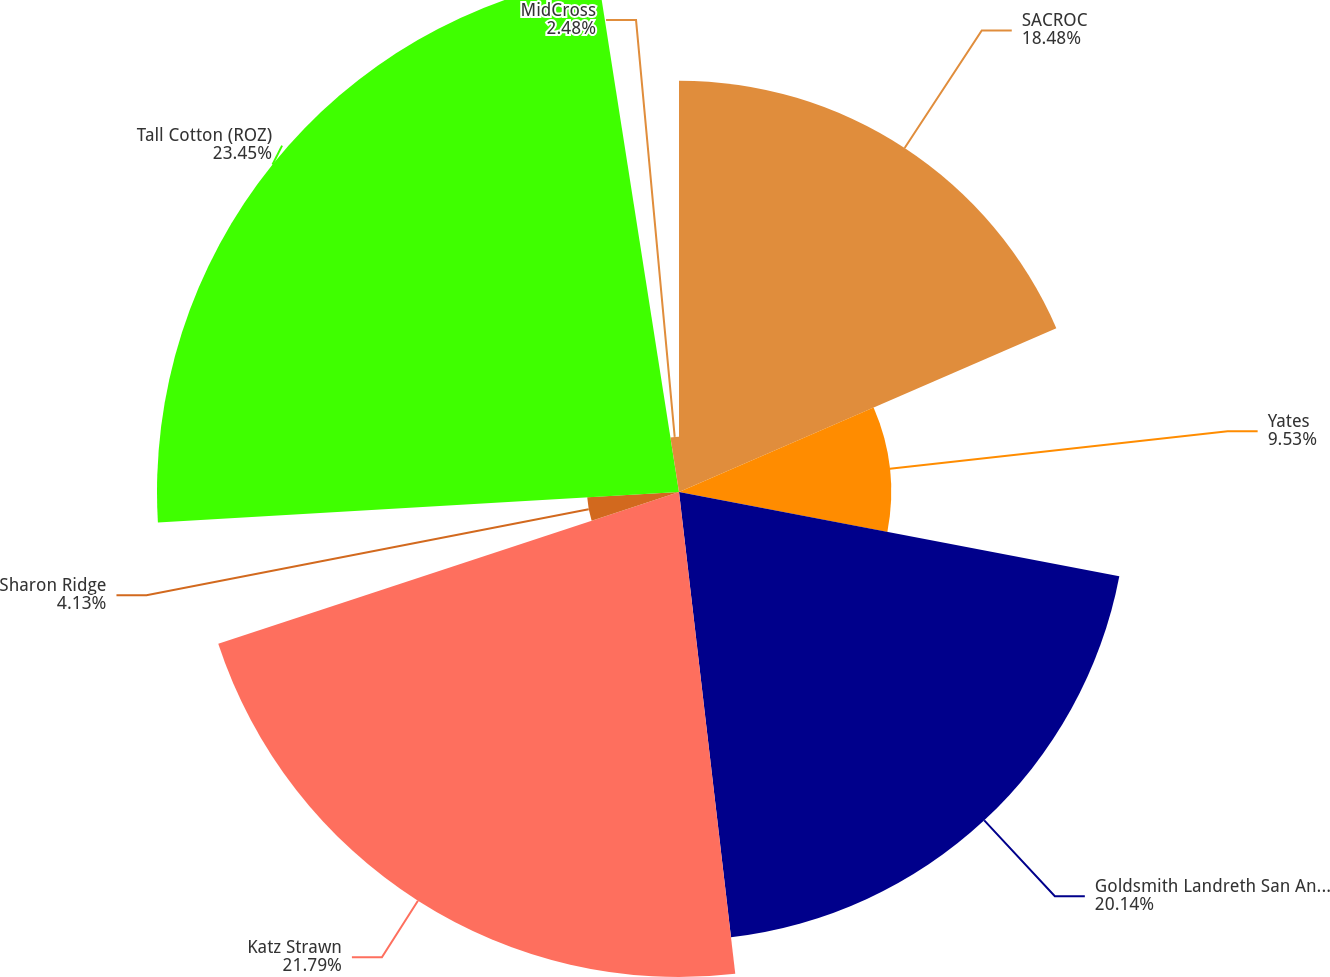<chart> <loc_0><loc_0><loc_500><loc_500><pie_chart><fcel>SACROC<fcel>Yates<fcel>Goldsmith Landreth San Andres<fcel>Katz Strawn<fcel>Sharon Ridge<fcel>Tall Cotton (ROZ)<fcel>MidCross<nl><fcel>18.48%<fcel>9.53%<fcel>20.14%<fcel>21.79%<fcel>4.13%<fcel>23.45%<fcel>2.48%<nl></chart> 